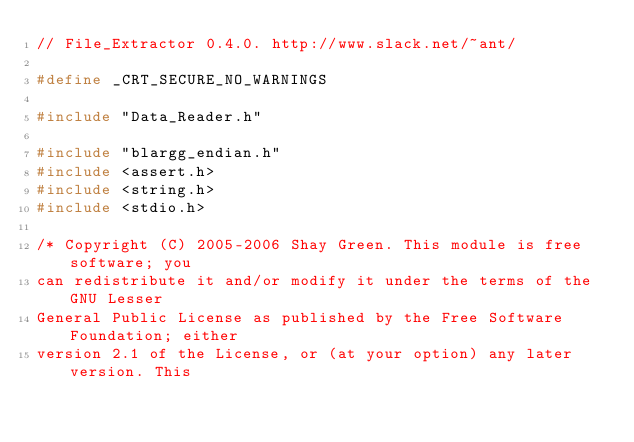Convert code to text. <code><loc_0><loc_0><loc_500><loc_500><_C++_>// File_Extractor 0.4.0. http://www.slack.net/~ant/

#define _CRT_SECURE_NO_WARNINGS

#include "Data_Reader.h"

#include "blargg_endian.h"
#include <assert.h>
#include <string.h>
#include <stdio.h>

/* Copyright (C) 2005-2006 Shay Green. This module is free software; you
can redistribute it and/or modify it under the terms of the GNU Lesser
General Public License as published by the Free Software Foundation; either
version 2.1 of the License, or (at your option) any later version. This</code> 